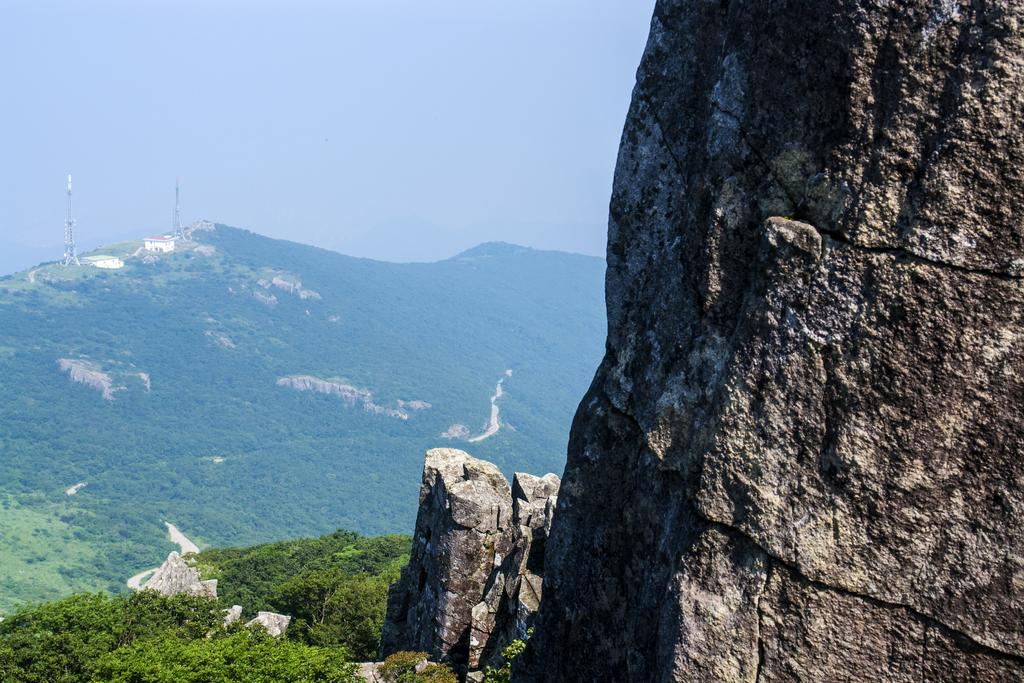What type of natural features can be seen in the image? There are rocks, trees, and mountains in the image. Can you describe the sky in the image? The sky appears gloomy in the image. What type of pen is visible in the image? There is no pen present in the image. What type of net can be seen in the image? There is no net present in the image. 